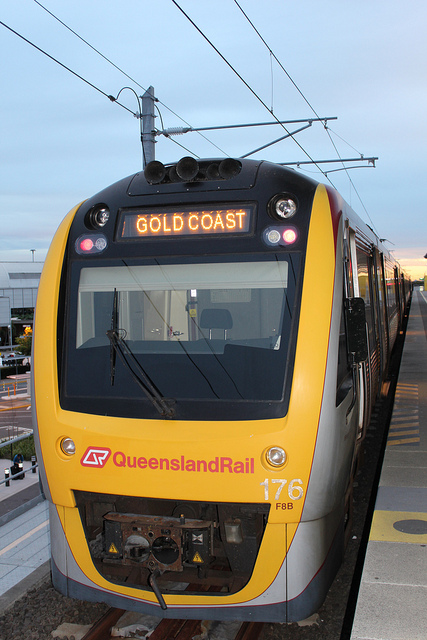Please identify all text content in this image. GOLD COAST QueenslandRail 176 F8B 